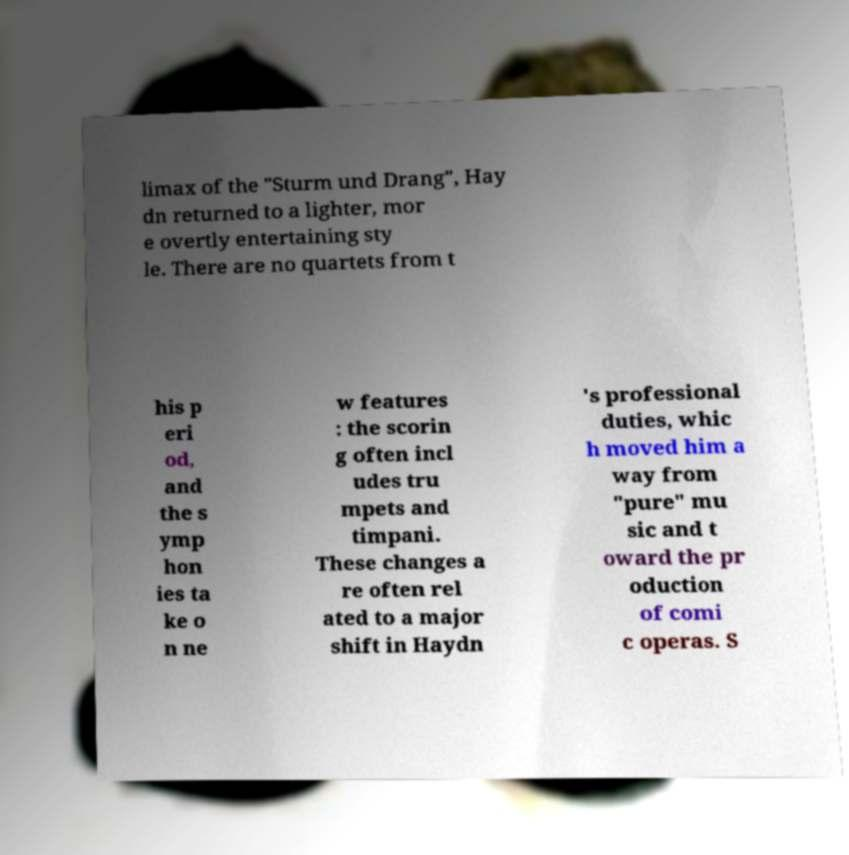Please identify and transcribe the text found in this image. limax of the "Sturm und Drang", Hay dn returned to a lighter, mor e overtly entertaining sty le. There are no quartets from t his p eri od, and the s ymp hon ies ta ke o n ne w features : the scorin g often incl udes tru mpets and timpani. These changes a re often rel ated to a major shift in Haydn 's professional duties, whic h moved him a way from "pure" mu sic and t oward the pr oduction of comi c operas. S 